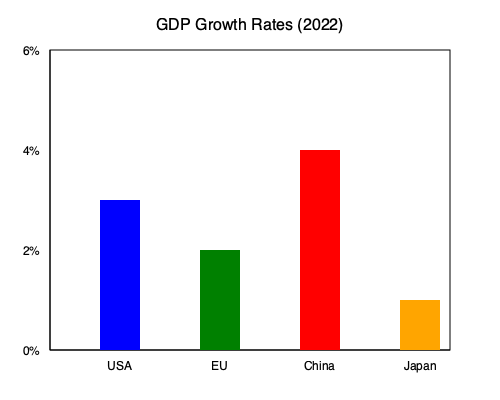Based on the bar chart showing GDP growth rates for different economies in 2022, which country experienced the highest growth rate, and what implications might this have for global economic dynamics and policy decisions by central banks? To answer this question, we need to analyze the bar chart and consider the broader economic context:

1. Identify the highest growth rate:
   - USA: approximately 3%
   - EU: approximately 2%
   - China: approximately 4%
   - Japan: approximately 1%

   China has the highest bar, indicating the highest GDP growth rate at about 4%.

2. Implications for global economic dynamics:
   a) Shift in economic power: China's higher growth rate suggests a continued shift in global economic power towards Asia.
   b) Trade patterns: Faster growth in China may lead to increased demand for imports, potentially benefiting its trading partners.
   c) Currency valuations: Strong growth could put upward pressure on the Chinese yuan, affecting global currency markets.

3. Implications for central bank policy decisions:
   a) Monetary policy divergence: Central banks in slower-growing economies (e.g., Japan, EU) may maintain more accommodative policies, while China's central bank might consider tightening to prevent overheating.
   b) Interest rate differentials: Higher growth rates may lead to higher interest rates in China, affecting global capital flows.
   c) Inflation concerns: Rapid growth in China could contribute to global inflationary pressures, influencing other central banks' policy decisions.
   d) Exchange rate policies: Other countries might adjust their exchange rate policies in response to China's strong growth to maintain export competitiveness.

4. Considerations for aspiring central bankers:
   - Monitor spillover effects from China's growth on domestic economies.
   - Assess the impact on global supply chains and commodity prices.
   - Consider the implications for financial stability and capital flows.
   - Evaluate the need for international policy coordination in response to divergent growth rates.
Answer: China had the highest growth rate (4%), potentially leading to shifts in global economic power, trade patterns, and monetary policies, requiring careful consideration by central banks worldwide. 